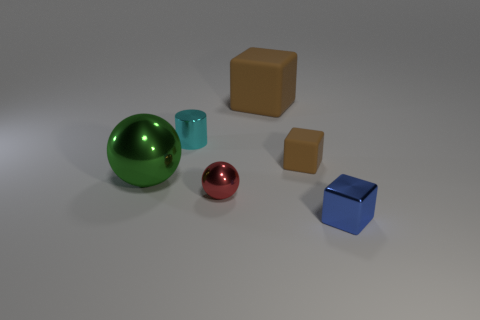Add 3 tiny blue things. How many objects exist? 9 Subtract all brown rubber blocks. How many blocks are left? 1 Subtract all blue blocks. How many blocks are left? 2 Subtract 1 blocks. How many blocks are left? 2 Subtract all cylinders. How many objects are left? 5 Subtract all cyan cubes. Subtract all yellow spheres. How many cubes are left? 3 Subtract all green cylinders. How many red spheres are left? 1 Subtract all small rubber things. Subtract all spheres. How many objects are left? 3 Add 5 big rubber blocks. How many big rubber blocks are left? 6 Add 6 tiny yellow matte cubes. How many tiny yellow matte cubes exist? 6 